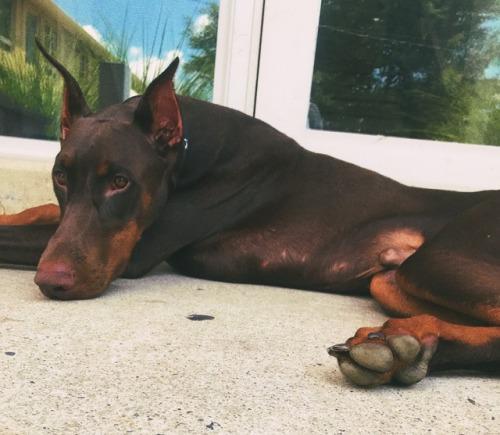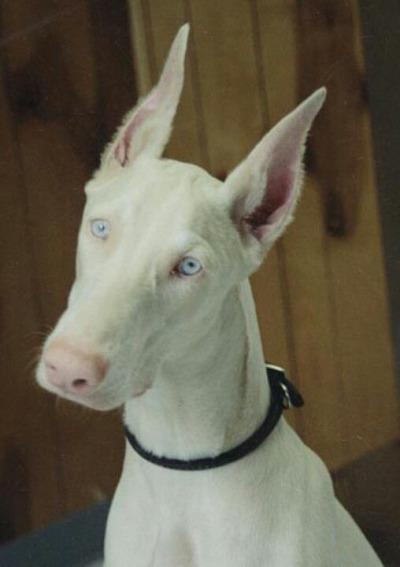The first image is the image on the left, the second image is the image on the right. Given the left and right images, does the statement "A dog in one of the images is solid white, and one dog has a very visible collar." hold true? Answer yes or no. Yes. 